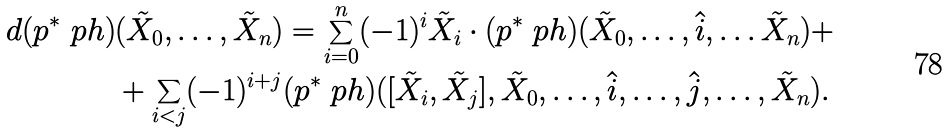<formula> <loc_0><loc_0><loc_500><loc_500>d ( p ^ { * } \ p h ) & ( \tilde { X } _ { 0 } , \dots , \tilde { X } _ { n } ) = \sum _ { i = 0 } ^ { n } ( - 1 ) ^ { i } \tilde { X } _ { i } \cdot ( p ^ { * } \ p h ) ( \tilde { X } _ { 0 } , \dots , \hat { i } , \dots \tilde { X } _ { n } ) + \\ & + \sum _ { i < j } ( - 1 ) ^ { i + j } ( p ^ { * } \ p h ) ( [ \tilde { X } _ { i } , \tilde { X } _ { j } ] , \tilde { X } _ { 0 } , \dots , \hat { i } , \dots , \hat { j } , \dots , \tilde { X } _ { n } ) .</formula> 